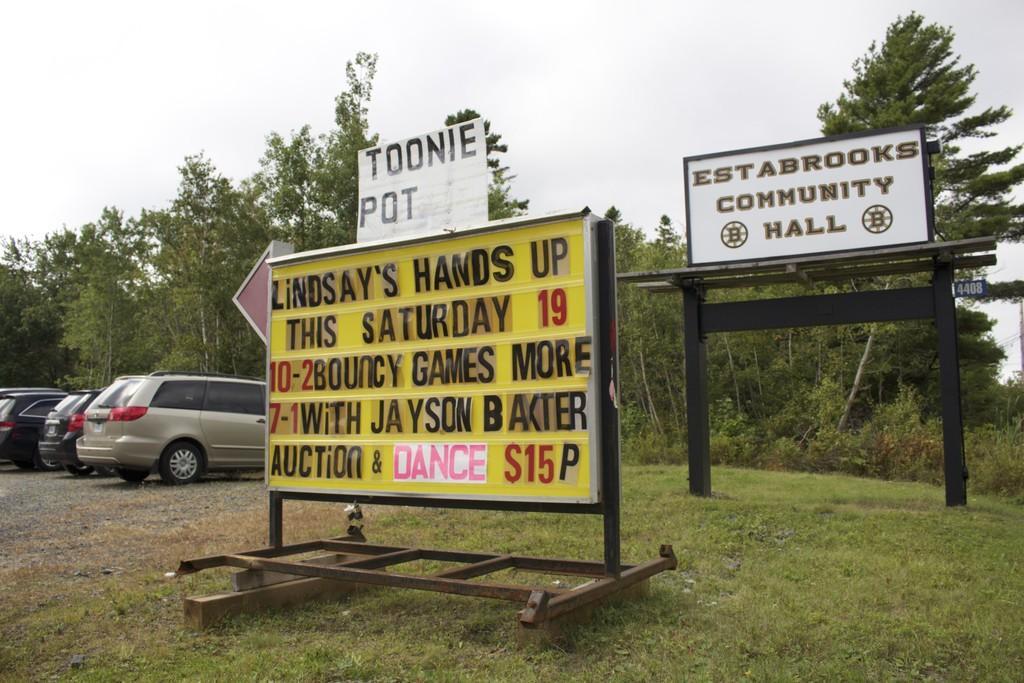Can you describe this image briefly? In the center of the image we can see the banners, grass and a few other objects. On the banners, we can see some text. In the background, we can see the sky, clouds, trees, vehicles, grass and a few other objects. 